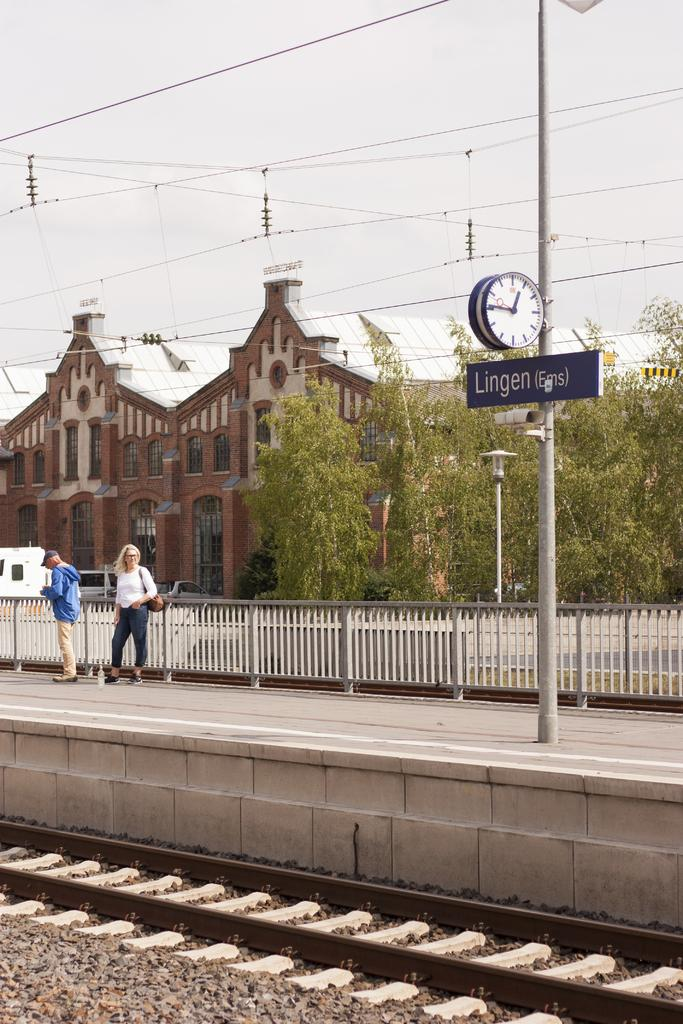<image>
Describe the image concisely. the word Lingen that is on a sign 